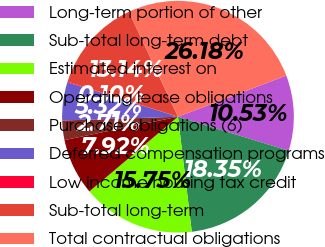Convert chart. <chart><loc_0><loc_0><loc_500><loc_500><pie_chart><fcel>Long-term portion of other<fcel>Sub-total long-term debt<fcel>Estimated interest on<fcel>Operating lease obligations<fcel>Purchase obligations (6)<fcel>Deferred compensation programs<fcel>Low income housing tax credit<fcel>Sub-total long-term<fcel>Total contractual obligations<nl><fcel>10.53%<fcel>18.35%<fcel>15.75%<fcel>7.92%<fcel>2.71%<fcel>5.32%<fcel>0.1%<fcel>13.14%<fcel>26.18%<nl></chart> 